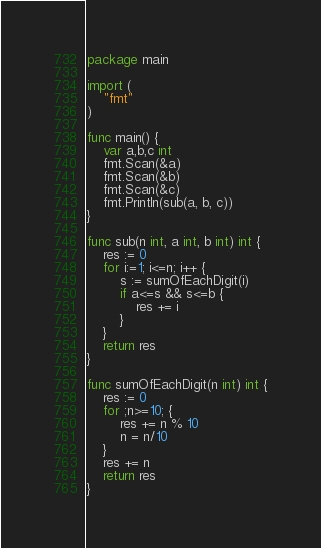Convert code to text. <code><loc_0><loc_0><loc_500><loc_500><_Go_>package main

import (
	"fmt"
)

func main() {
	var a,b,c int
	fmt.Scan(&a)
	fmt.Scan(&b)
	fmt.Scan(&c)
	fmt.Println(sub(a, b, c))
}

func sub(n int, a int, b int) int {
	res := 0
	for i:=1; i<=n; i++ {
		s := sumOfEachDigit(i)
		if a<=s && s<=b {
			res += i
		}
	}
	return res
}

func sumOfEachDigit(n int) int {
	res := 0
	for ;n>=10; {
		res += n % 10
		n = n/10
	}
	res += n
	return res
}</code> 